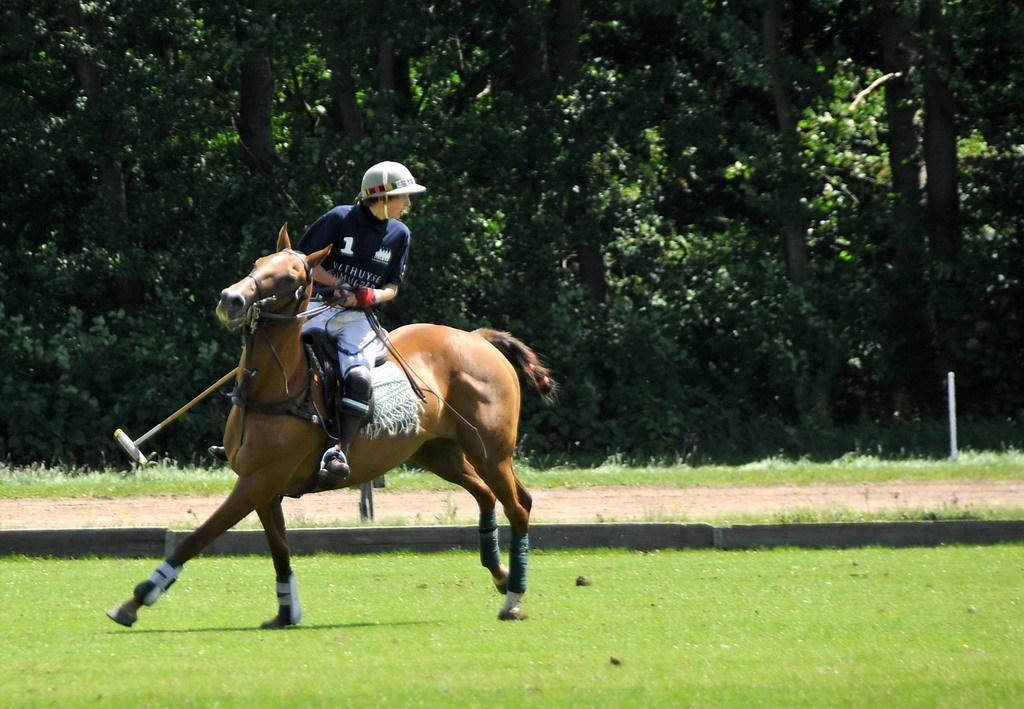What is the main subject of the image? There is a person in the image. What is the person doing in the image? The person is riding a horse and playing polo. What can be seen in the background of the image? There are trees in the background of the image. What type of terrain is visible at the bottom of the image? There is grass on the ground at the bottom of the image. What type of scarecrow can be seen in the image? There is no scarecrow present in the image. Where did the person go on vacation before playing polo in the image? The provided facts do not mention any information about the person's previous vacation, so it cannot be determined from the image. 